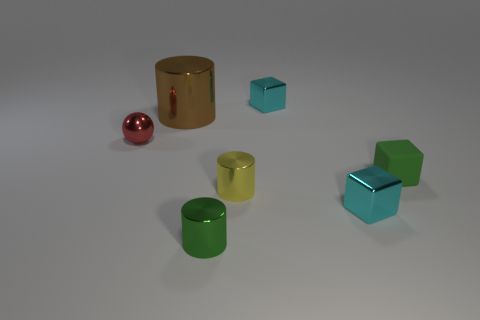Add 1 cyan metallic cubes. How many objects exist? 8 Subtract all cylinders. How many objects are left? 4 Subtract 0 yellow spheres. How many objects are left? 7 Subtract all tiny brown spheres. Subtract all green shiny cylinders. How many objects are left? 6 Add 1 small cyan shiny things. How many small cyan shiny things are left? 3 Add 1 red shiny things. How many red shiny things exist? 2 